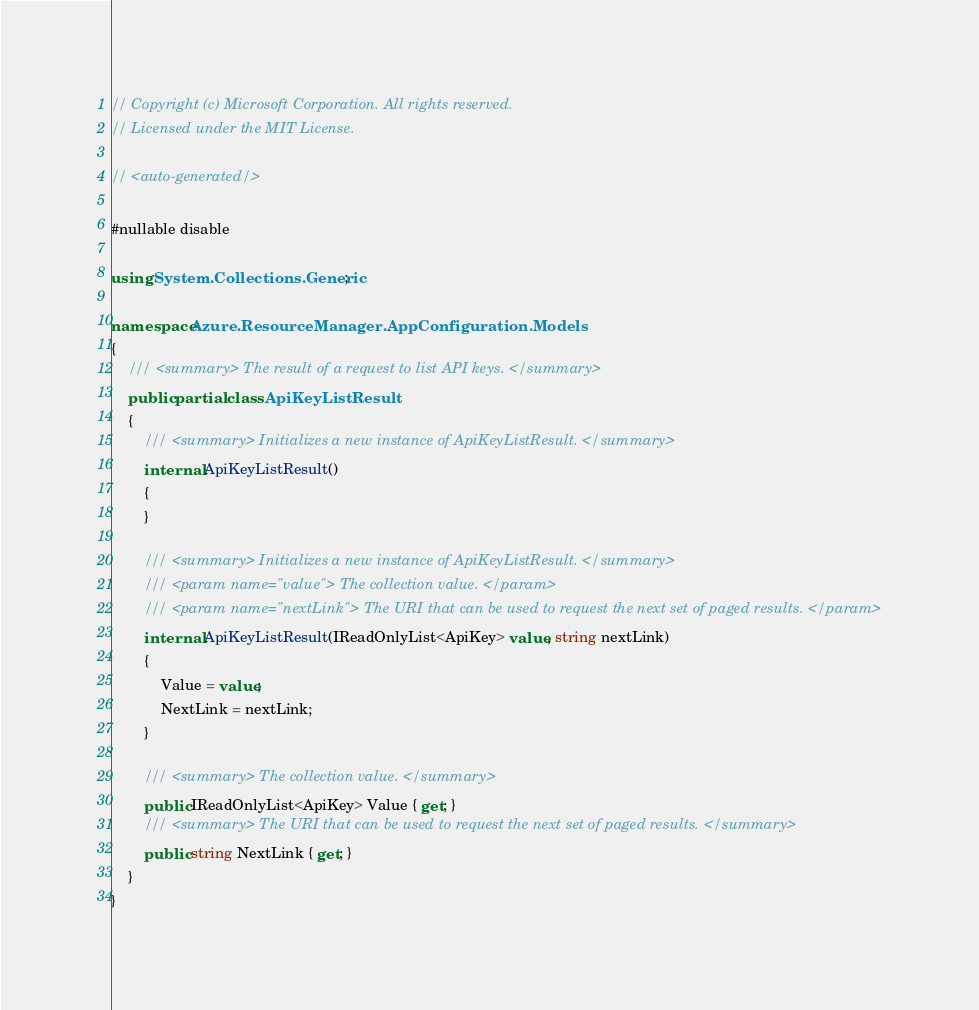Convert code to text. <code><loc_0><loc_0><loc_500><loc_500><_C#_>// Copyright (c) Microsoft Corporation. All rights reserved.
// Licensed under the MIT License.

// <auto-generated/>

#nullable disable

using System.Collections.Generic;

namespace Azure.ResourceManager.AppConfiguration.Models
{
    /// <summary> The result of a request to list API keys. </summary>
    public partial class ApiKeyListResult
    {
        /// <summary> Initializes a new instance of ApiKeyListResult. </summary>
        internal ApiKeyListResult()
        {
        }

        /// <summary> Initializes a new instance of ApiKeyListResult. </summary>
        /// <param name="value"> The collection value. </param>
        /// <param name="nextLink"> The URI that can be used to request the next set of paged results. </param>
        internal ApiKeyListResult(IReadOnlyList<ApiKey> value, string nextLink)
        {
            Value = value;
            NextLink = nextLink;
        }

        /// <summary> The collection value. </summary>
        public IReadOnlyList<ApiKey> Value { get; }
        /// <summary> The URI that can be used to request the next set of paged results. </summary>
        public string NextLink { get; }
    }
}
</code> 